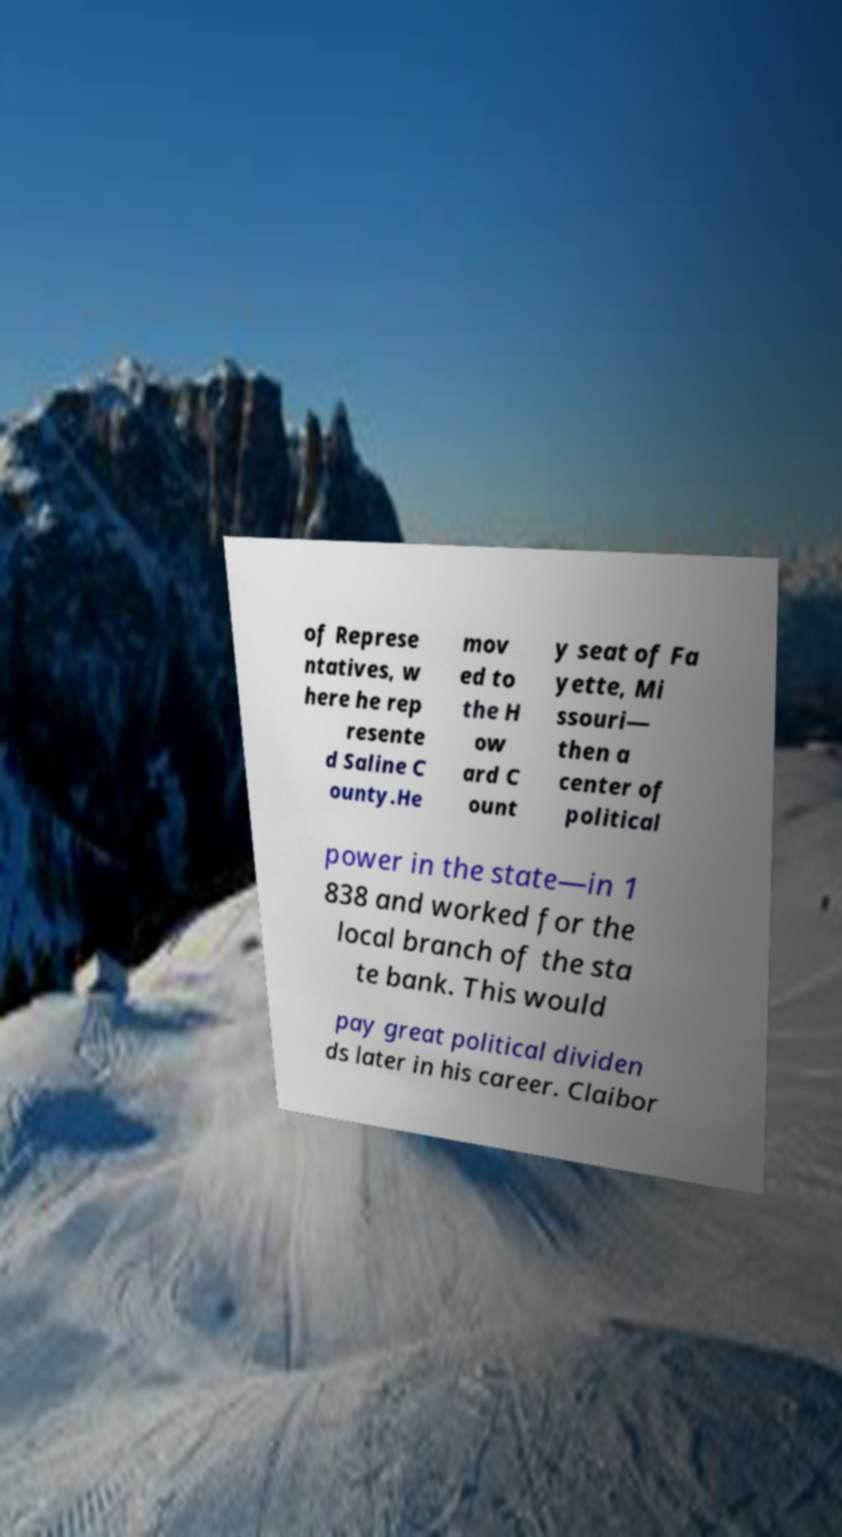Could you extract and type out the text from this image? of Represe ntatives, w here he rep resente d Saline C ounty.He mov ed to the H ow ard C ount y seat of Fa yette, Mi ssouri— then a center of political power in the state—in 1 838 and worked for the local branch of the sta te bank. This would pay great political dividen ds later in his career. Claibor 